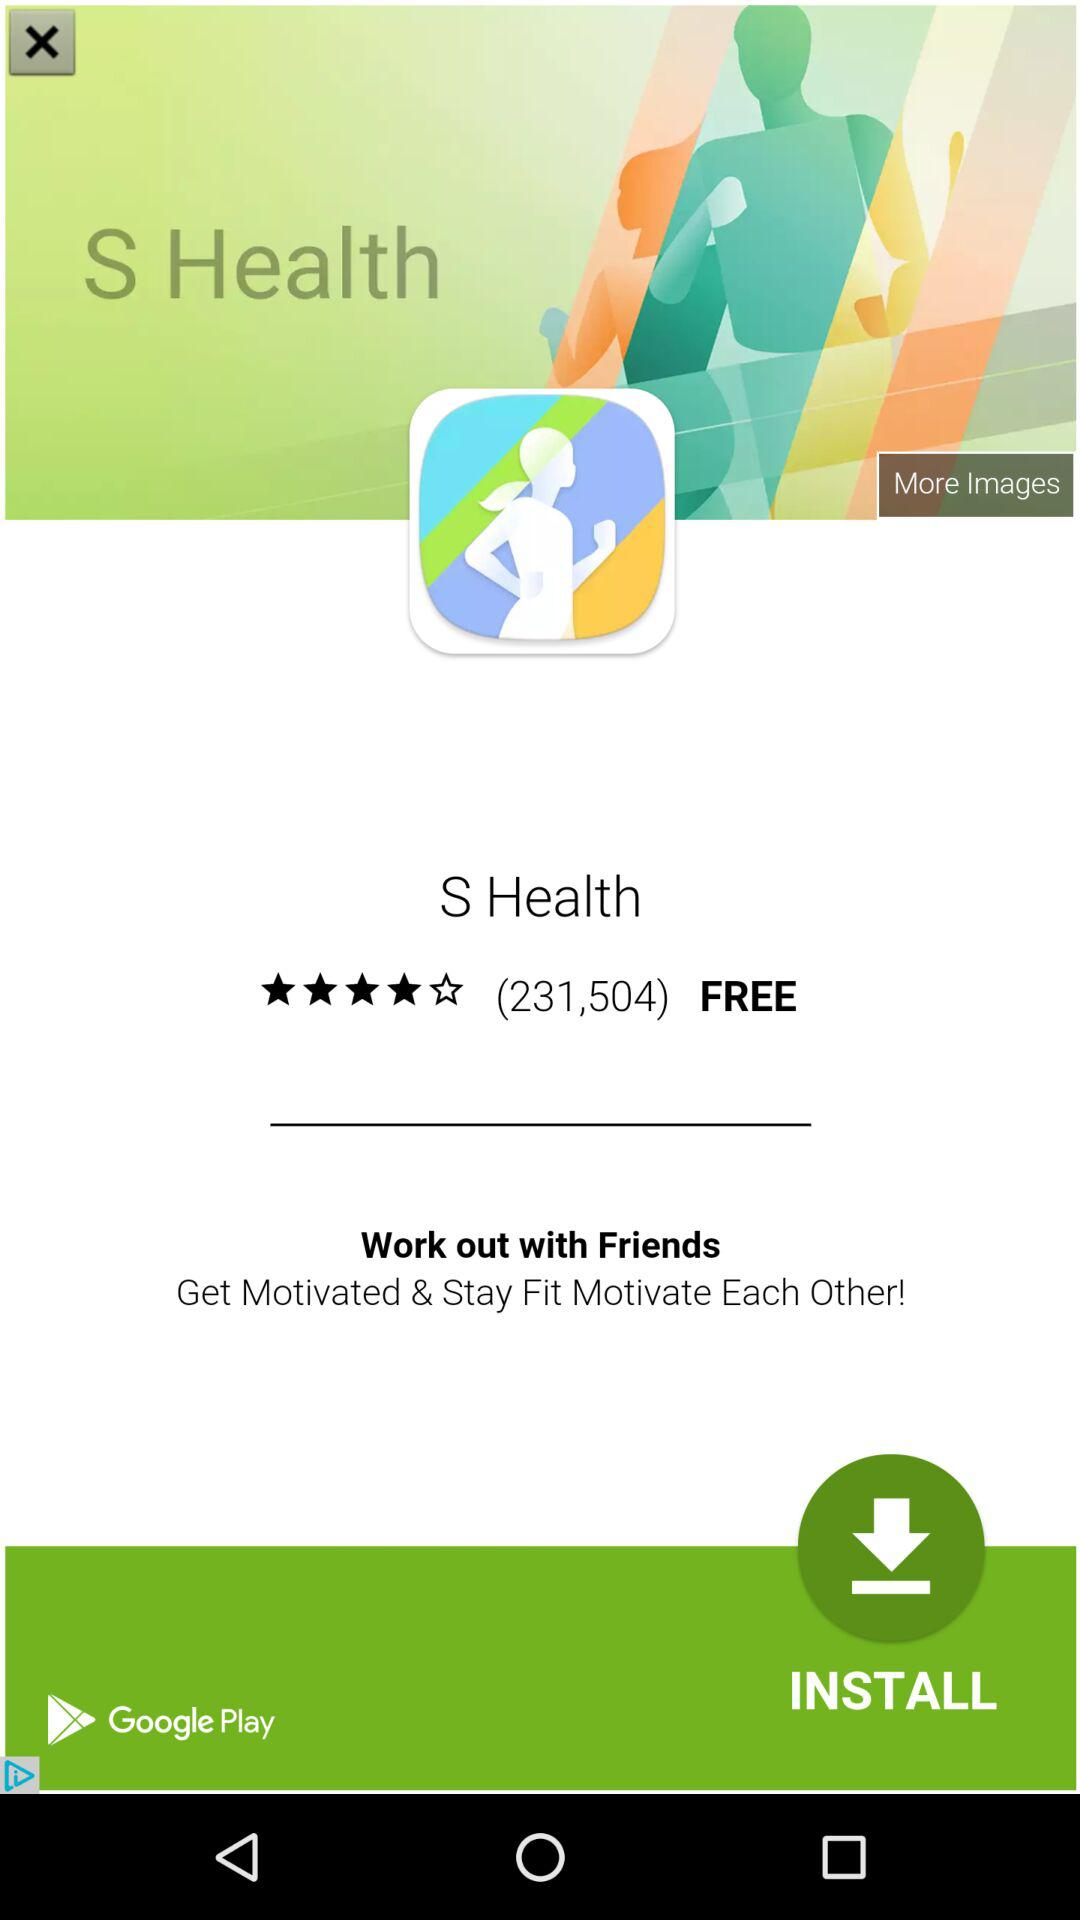What are the workouts on the list? The workouts on the list are "Speed skips", "Squat", "Push-ups", "Crunch", "Speed skips", "Squat", "Push-ups" and "Crunch". 